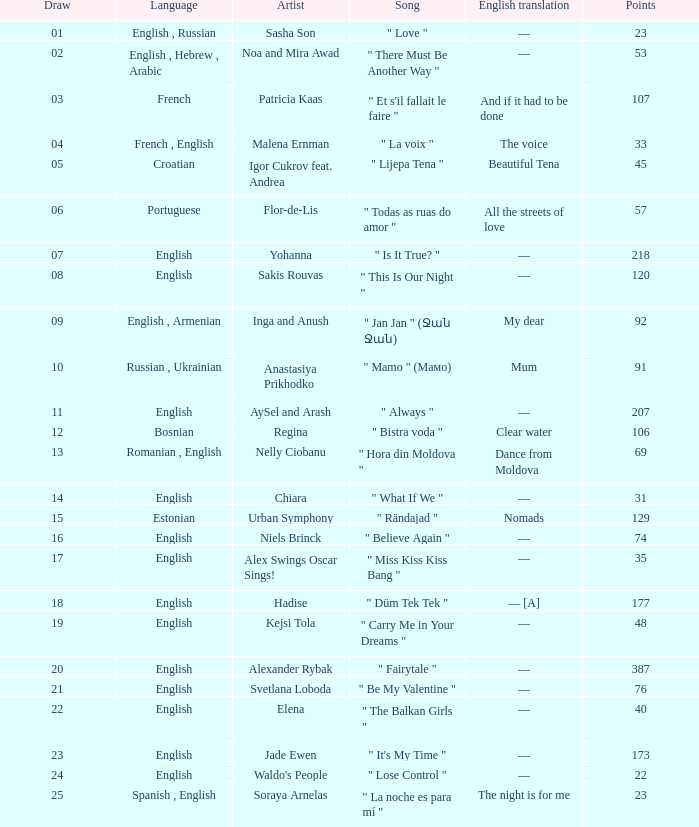What was the english translation for the song by svetlana loboda? —. 